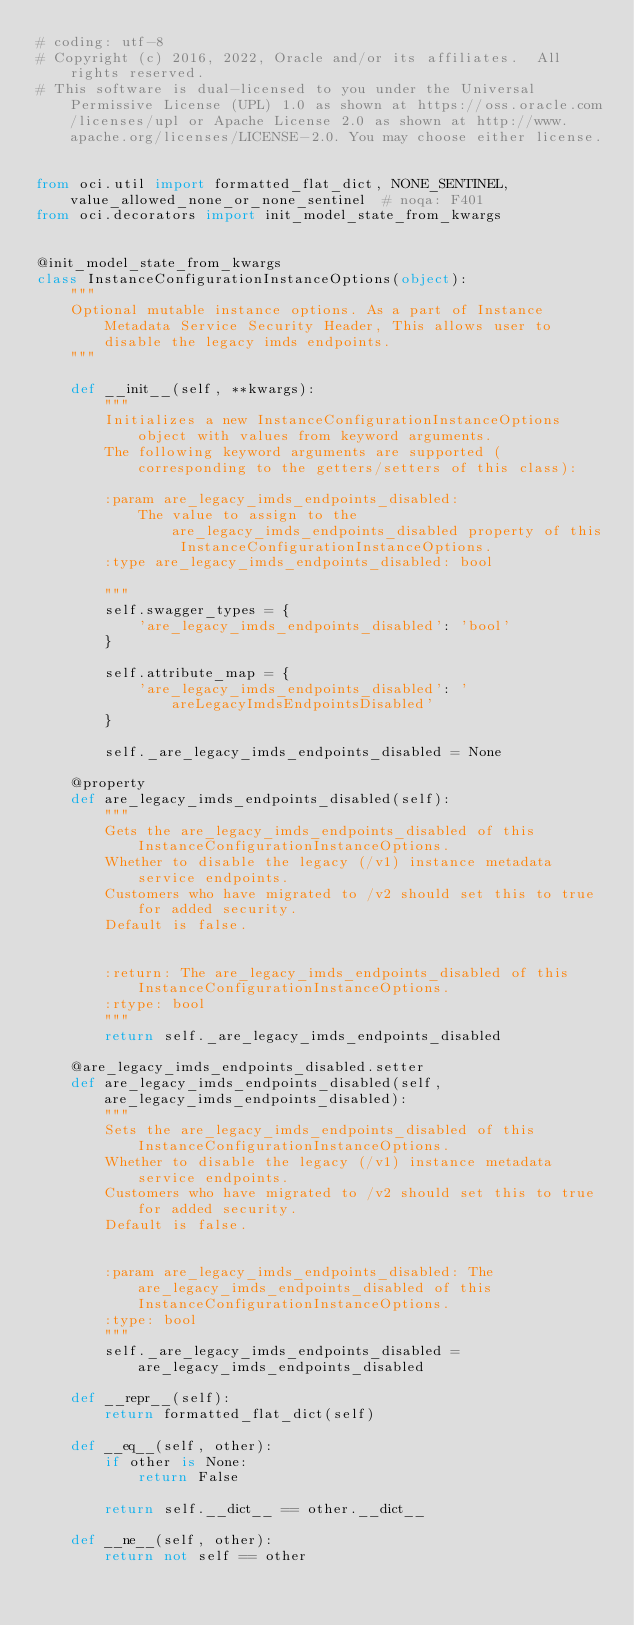Convert code to text. <code><loc_0><loc_0><loc_500><loc_500><_Python_># coding: utf-8
# Copyright (c) 2016, 2022, Oracle and/or its affiliates.  All rights reserved.
# This software is dual-licensed to you under the Universal Permissive License (UPL) 1.0 as shown at https://oss.oracle.com/licenses/upl or Apache License 2.0 as shown at http://www.apache.org/licenses/LICENSE-2.0. You may choose either license.


from oci.util import formatted_flat_dict, NONE_SENTINEL, value_allowed_none_or_none_sentinel  # noqa: F401
from oci.decorators import init_model_state_from_kwargs


@init_model_state_from_kwargs
class InstanceConfigurationInstanceOptions(object):
    """
    Optional mutable instance options. As a part of Instance Metadata Service Security Header, This allows user to disable the legacy imds endpoints.
    """

    def __init__(self, **kwargs):
        """
        Initializes a new InstanceConfigurationInstanceOptions object with values from keyword arguments.
        The following keyword arguments are supported (corresponding to the getters/setters of this class):

        :param are_legacy_imds_endpoints_disabled:
            The value to assign to the are_legacy_imds_endpoints_disabled property of this InstanceConfigurationInstanceOptions.
        :type are_legacy_imds_endpoints_disabled: bool

        """
        self.swagger_types = {
            'are_legacy_imds_endpoints_disabled': 'bool'
        }

        self.attribute_map = {
            'are_legacy_imds_endpoints_disabled': 'areLegacyImdsEndpointsDisabled'
        }

        self._are_legacy_imds_endpoints_disabled = None

    @property
    def are_legacy_imds_endpoints_disabled(self):
        """
        Gets the are_legacy_imds_endpoints_disabled of this InstanceConfigurationInstanceOptions.
        Whether to disable the legacy (/v1) instance metadata service endpoints.
        Customers who have migrated to /v2 should set this to true for added security.
        Default is false.


        :return: The are_legacy_imds_endpoints_disabled of this InstanceConfigurationInstanceOptions.
        :rtype: bool
        """
        return self._are_legacy_imds_endpoints_disabled

    @are_legacy_imds_endpoints_disabled.setter
    def are_legacy_imds_endpoints_disabled(self, are_legacy_imds_endpoints_disabled):
        """
        Sets the are_legacy_imds_endpoints_disabled of this InstanceConfigurationInstanceOptions.
        Whether to disable the legacy (/v1) instance metadata service endpoints.
        Customers who have migrated to /v2 should set this to true for added security.
        Default is false.


        :param are_legacy_imds_endpoints_disabled: The are_legacy_imds_endpoints_disabled of this InstanceConfigurationInstanceOptions.
        :type: bool
        """
        self._are_legacy_imds_endpoints_disabled = are_legacy_imds_endpoints_disabled

    def __repr__(self):
        return formatted_flat_dict(self)

    def __eq__(self, other):
        if other is None:
            return False

        return self.__dict__ == other.__dict__

    def __ne__(self, other):
        return not self == other
</code> 